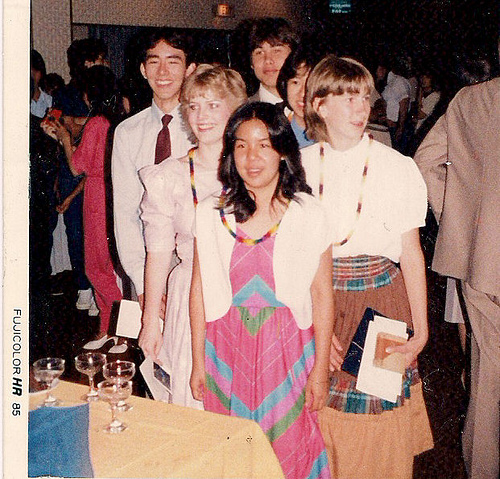Read all the text in this image. FUJICOLOR HR 74 